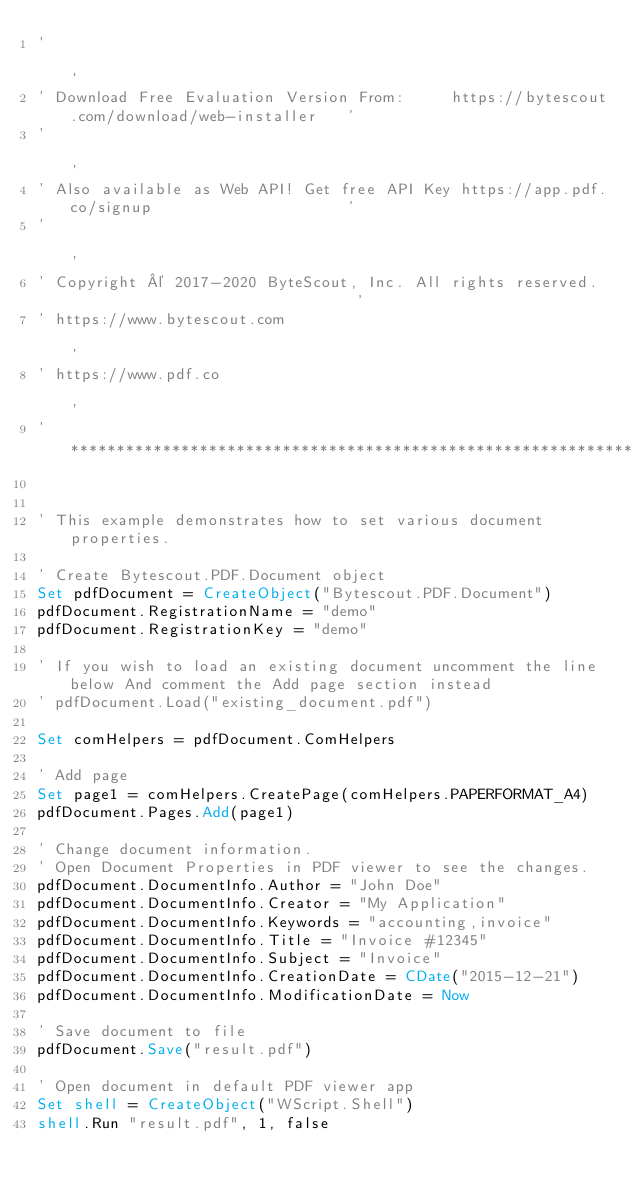<code> <loc_0><loc_0><loc_500><loc_500><_VisualBasic_>'                                                                                           '
' Download Free Evaluation Version From:     https://bytescout.com/download/web-installer   '
'                                                                                           '
' Also available as Web API! Get free API Key https://app.pdf.co/signup                     '
'                                                                                           '
' Copyright © 2017-2020 ByteScout, Inc. All rights reserved.                                '
' https://www.bytescout.com                                                                 '
' https://www.pdf.co                                                                        '
'*******************************************************************************************'


' This example demonstrates how to set various document properties.

' Create Bytescout.PDF.Document object
Set pdfDocument = CreateObject("Bytescout.PDF.Document")
pdfDocument.RegistrationName = "demo"
pdfDocument.RegistrationKey = "demo"

' If you wish to load an existing document uncomment the line below And comment the Add page section instead
' pdfDocument.Load("existing_document.pdf")

Set comHelpers = pdfDocument.ComHelpers

' Add page
Set page1 = comHelpers.CreatePage(comHelpers.PAPERFORMAT_A4)
pdfDocument.Pages.Add(page1)

' Change document information.
' Open Document Properties in PDF viewer to see the changes.
pdfDocument.DocumentInfo.Author = "John Doe"
pdfDocument.DocumentInfo.Creator = "My Application"
pdfDocument.DocumentInfo.Keywords = "accounting,invoice"
pdfDocument.DocumentInfo.Title = "Invoice #12345"
pdfDocument.DocumentInfo.Subject = "Invoice"
pdfDocument.DocumentInfo.CreationDate = CDate("2015-12-21")
pdfDocument.DocumentInfo.ModificationDate = Now

' Save document to file
pdfDocument.Save("result.pdf")

' Open document in default PDF viewer app
Set shell = CreateObject("WScript.Shell")
shell.Run "result.pdf", 1, false
</code> 